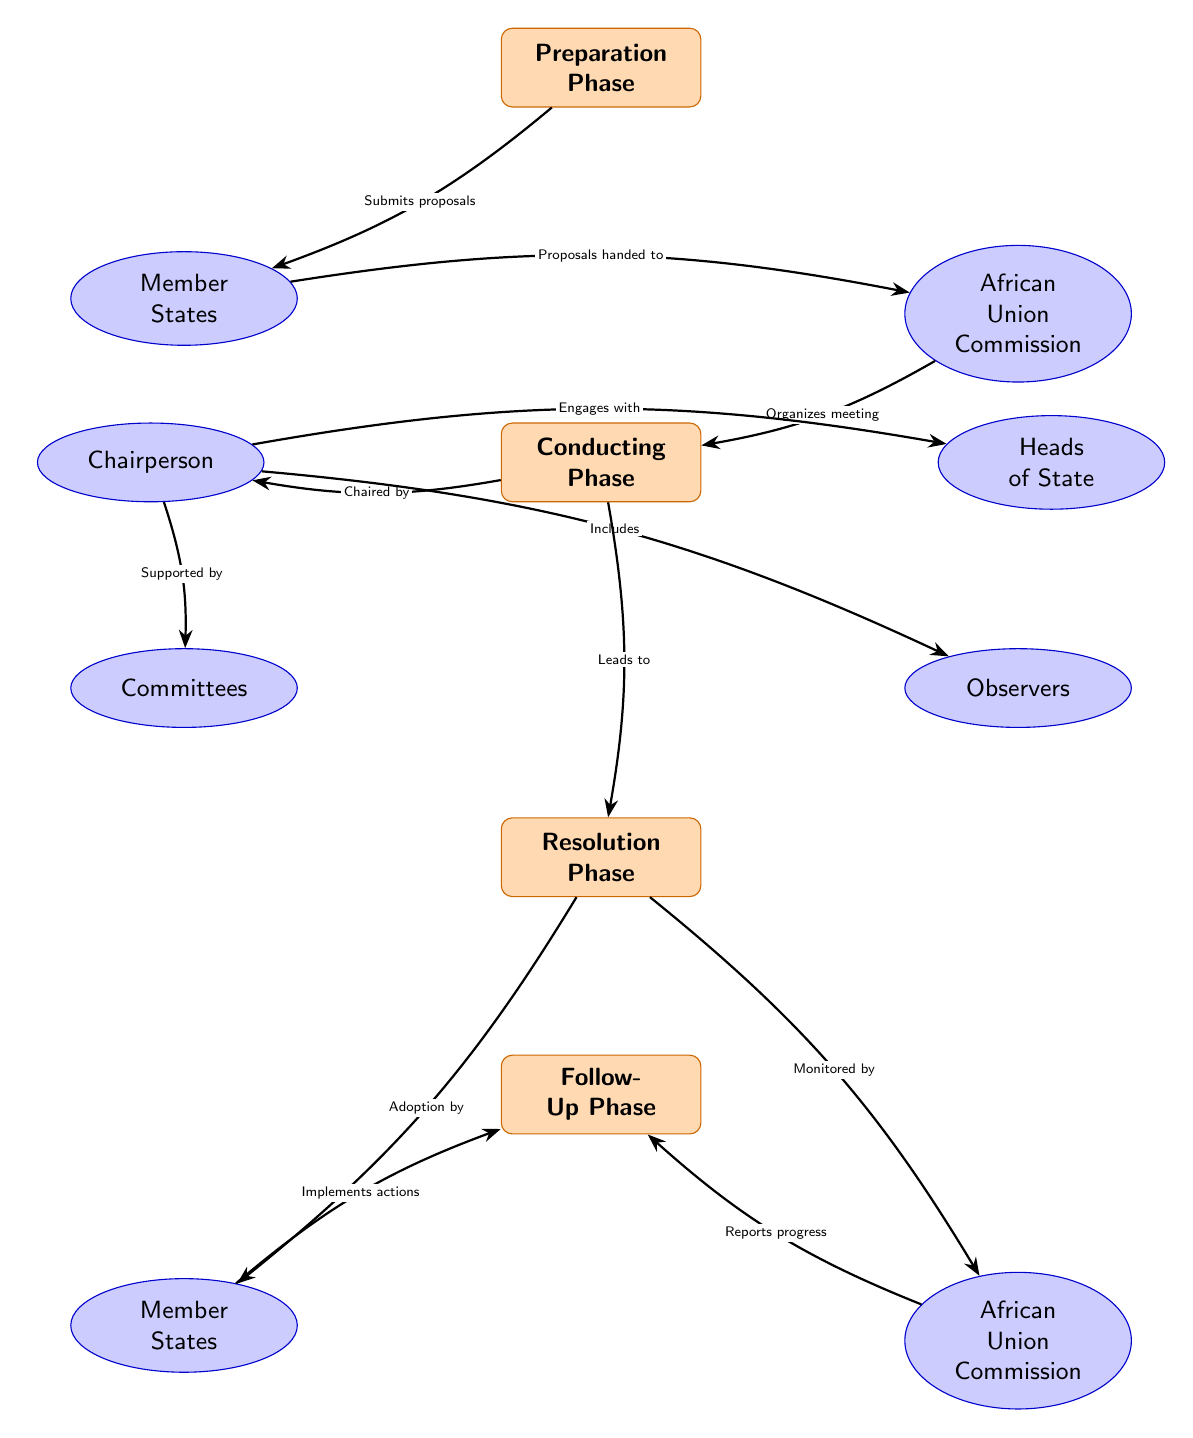What phase comes after the Preparation Phase? The diagram shows a sequence of phases, and the phase that directly follows the Preparation Phase is the Conducting Phase.
Answer: Conducting Phase Who organizes the meeting? According to the diagram, it is the African Union Commission that organizes the meeting after member states submit their proposals.
Answer: African Union Commission What role does the Chairperson have during the Conducting Phase? The diagram indicates that the Chairperson engages with Heads of State, is supported by Committees, and includes Observers during the Conducting Phase.
Answer: Chairperson How many phases are depicted in the diagram? After carefully counting each labeled phase in the diagram, it can be confirmed that there are four distinct phases present.
Answer: Four What is the final action taken by Member States in the Follow-Up Phase? The diagram shows that in the Follow-Up Phase, Member States implement actions based on the resolutions adopted previously.
Answer: Implements actions Which actor monitors progress in the Follow-Up Phase? The diagram explicitly states that the African Union Commission is responsible for monitoring progress during the Follow-Up Phase.
Answer: African Union Commission What is the relationship between the Conducting Phase and the Resolution Phase? The diagram illustrates that the Conducting Phase leads directly to the Resolution Phase, signifying a crucial transition after the meetings are conducted.
Answer: Leads to What do Observers do during the Conducting Phase? The diagram mentions that Observers are included during the Conducting Phase, indicating their participation and possibly their role in the meetings.
Answer: Includes Who submits proposals in the Preparation Phase? From the diagram, it is clear that the Member States are the entities that submit proposals during the Preparation Phase.
Answer: Member States 